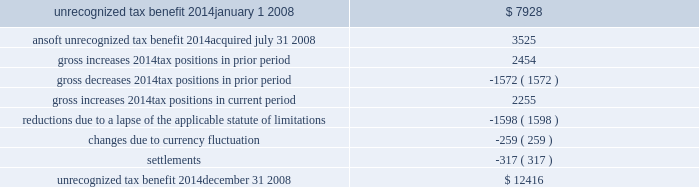The following is a reconciliation of the total amounts of unrecognized tax benefits for the year : ( in thousands ) .
Included in the balance of unrecognized tax benefits at december 31 , 2008 are $ 5.6 million of tax benefits that , if recognized , would affect the effective tax rate .
Also included in the balance of unrecognized tax benefits at december 31 , 2008 are $ 5.0 million of tax benefits that , if recognized , would result in a decrease to goodwill recorded in purchase business combinations , and $ 1.9 million of tax benefits that , if recognized , would result in adjustments to other tax accounts , primarily deferred taxes .
The company believes it is reasonably possible that uncertain tax positions of approximately $ 2.6 million as of december 31 , 2008 will be resolved within the next twelve months .
The company recognizes interest and penalties related to unrecognized tax benefits as income tax expense .
Related to the uncertain tax benefits noted above , the company recorded interest of $ 171000 during 2008 .
Penalties recorded during 2008 were insignificant .
In total , as of december 31 , 2008 , the company has recognized a liability for penalties of $ 498000 and interest of $ 1.8 million .
The company is subject to taxation in the u.s .
And various states and foreign jurisdictions .
The company 2019s 2005 through 2008 tax years are open to examination by the internal revenue service .
The 2005 and 2006 federal returns are currently under examination .
The company also has various foreign subsidiaries with tax filings under examination , as well as numerous foreign and state tax filings subject to examination for various years .
10 .
Pension and profit-sharing plans the company has 401 ( k ) /profit-sharing plans for all qualifying full-time domestic employees that permit participants to make contributions by salary reduction pursuant to section 401 ( k ) of the internal revenue code .
The company makes matching contributions on behalf of each eligible participant in an amount equal to 100% ( 100 % ) of the first 3% ( 3 % ) and an additional 25% ( 25 % ) of the next 5% ( 5 % ) , for a maximum total of 4.25% ( 4.25 % ) of the employee 2019s compensation .
The company may make a discretionary profit sharing contribution in the amount of 0% ( 0 % ) to 5% ( 5 % ) based on the participant 2019s eligible compensation , provided the employee is employed at the end of the year and has worked at least 1000 hours .
The qualifying domestic employees of the company 2019s ansoft subsidiary , acquired on july 31 , 2008 , also participate in a 401 ( k ) plan .
There is no matching employer contribution associated with this plan .
The company also maintains various defined contribution pension arrangements for its international employees .
Expenses related to the company 2019s retirement programs were $ 3.7 million in 2008 , $ 4.7 million in 2007 and $ 4.1 million in 2006 .
11 .
Non-compete and employment agreements employees of the company have signed agreements under which they have agreed not to disclose trade secrets or confidential information and , where legally permitted , that restrict engagement in or connection with any business that is competitive with the company anywhere in the world while employed by the company ( and .
In 2008 what was the percentage change in the unrecognized tax benefits? 
Computations: ((12416 - 7928) / 7928)
Answer: 0.56609. 